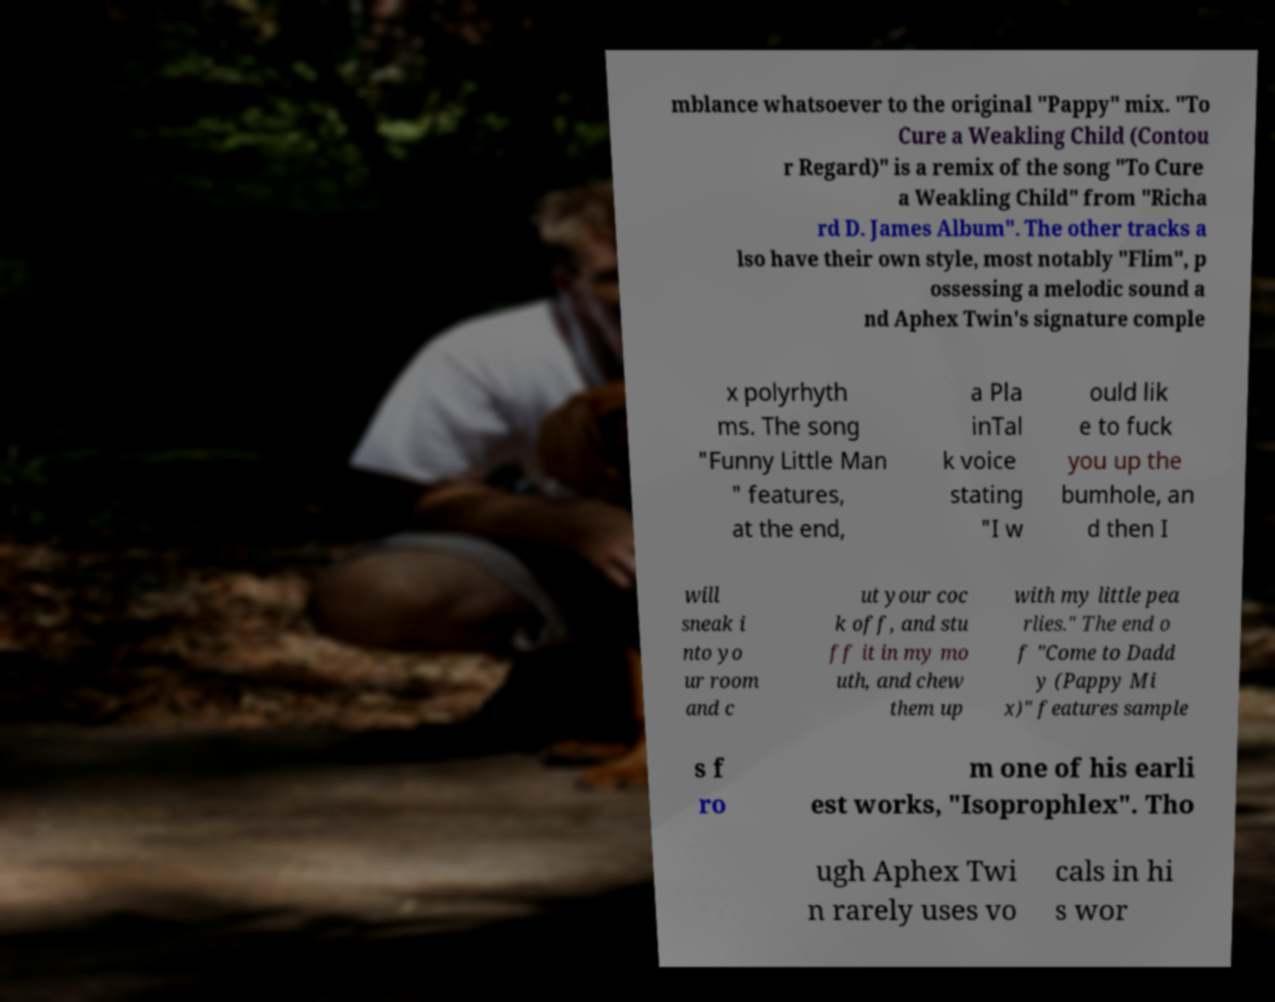I need the written content from this picture converted into text. Can you do that? mblance whatsoever to the original "Pappy" mix. "To Cure a Weakling Child (Contou r Regard)" is a remix of the song "To Cure a Weakling Child" from "Richa rd D. James Album". The other tracks a lso have their own style, most notably "Flim", p ossessing a melodic sound a nd Aphex Twin's signature comple x polyrhyth ms. The song "Funny Little Man " features, at the end, a Pla inTal k voice stating "I w ould lik e to fuck you up the bumhole, an d then I will sneak i nto yo ur room and c ut your coc k off, and stu ff it in my mo uth, and chew them up with my little pea rlies." The end o f "Come to Dadd y (Pappy Mi x)" features sample s f ro m one of his earli est works, "Isoprophlex". Tho ugh Aphex Twi n rarely uses vo cals in hi s wor 